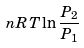Convert formula to latex. <formula><loc_0><loc_0><loc_500><loc_500>n R T \ln \frac { P _ { 2 } } { P _ { 1 } }</formula> 